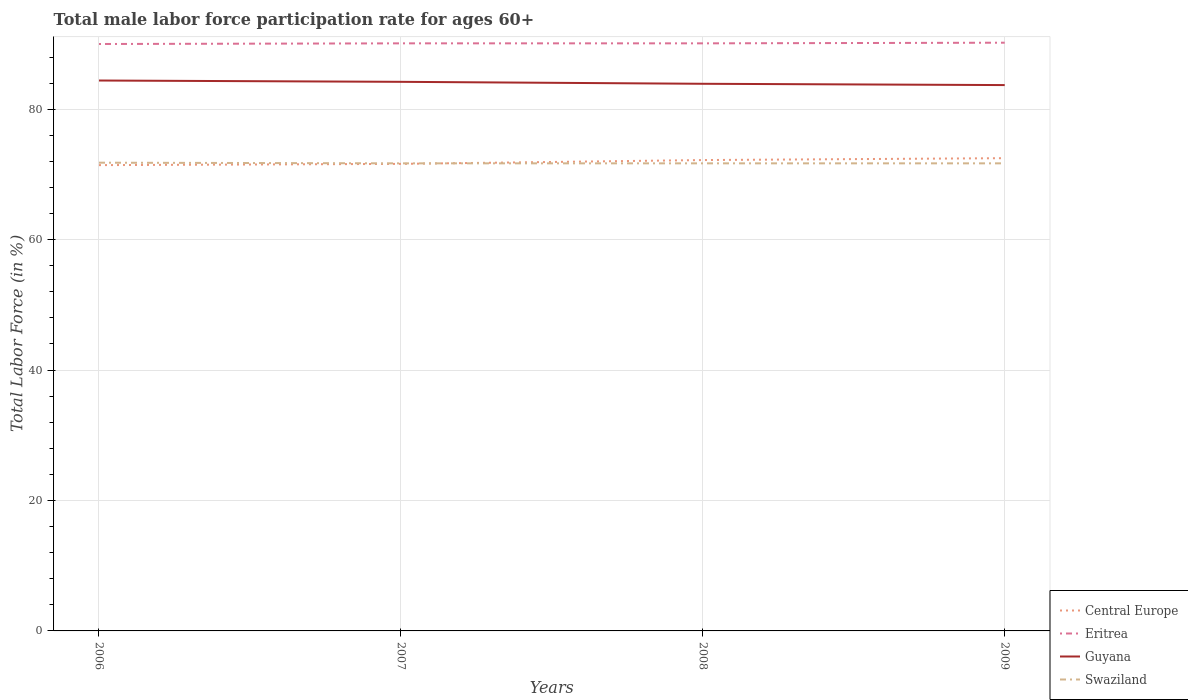How many different coloured lines are there?
Offer a very short reply. 4. Across all years, what is the maximum male labor force participation rate in Central Europe?
Your response must be concise. 71.43. What is the total male labor force participation rate in Guyana in the graph?
Your response must be concise. 0.5. What is the difference between the highest and the second highest male labor force participation rate in Swaziland?
Your answer should be compact. 0.1. What is the difference between the highest and the lowest male labor force participation rate in Eritrea?
Provide a succinct answer. 1. Is the male labor force participation rate in Swaziland strictly greater than the male labor force participation rate in Central Europe over the years?
Provide a short and direct response. No. How many lines are there?
Give a very brief answer. 4. What is the difference between two consecutive major ticks on the Y-axis?
Offer a terse response. 20. Are the values on the major ticks of Y-axis written in scientific E-notation?
Your answer should be very brief. No. Does the graph contain any zero values?
Make the answer very short. No. Where does the legend appear in the graph?
Give a very brief answer. Bottom right. What is the title of the graph?
Keep it short and to the point. Total male labor force participation rate for ages 60+. Does "Barbados" appear as one of the legend labels in the graph?
Provide a short and direct response. No. What is the label or title of the X-axis?
Ensure brevity in your answer.  Years. What is the label or title of the Y-axis?
Your answer should be very brief. Total Labor Force (in %). What is the Total Labor Force (in %) in Central Europe in 2006?
Offer a very short reply. 71.43. What is the Total Labor Force (in %) of Eritrea in 2006?
Ensure brevity in your answer.  90. What is the Total Labor Force (in %) of Guyana in 2006?
Make the answer very short. 84.4. What is the Total Labor Force (in %) of Swaziland in 2006?
Your answer should be very brief. 71.8. What is the Total Labor Force (in %) in Central Europe in 2007?
Offer a terse response. 71.62. What is the Total Labor Force (in %) of Eritrea in 2007?
Make the answer very short. 90.1. What is the Total Labor Force (in %) in Guyana in 2007?
Offer a very short reply. 84.2. What is the Total Labor Force (in %) in Swaziland in 2007?
Your answer should be very brief. 71.7. What is the Total Labor Force (in %) of Central Europe in 2008?
Offer a terse response. 72.2. What is the Total Labor Force (in %) in Eritrea in 2008?
Make the answer very short. 90.1. What is the Total Labor Force (in %) of Guyana in 2008?
Offer a very short reply. 83.9. What is the Total Labor Force (in %) in Swaziland in 2008?
Give a very brief answer. 71.7. What is the Total Labor Force (in %) of Central Europe in 2009?
Ensure brevity in your answer.  72.49. What is the Total Labor Force (in %) of Eritrea in 2009?
Provide a succinct answer. 90.2. What is the Total Labor Force (in %) in Guyana in 2009?
Offer a terse response. 83.7. What is the Total Labor Force (in %) of Swaziland in 2009?
Keep it short and to the point. 71.7. Across all years, what is the maximum Total Labor Force (in %) of Central Europe?
Offer a terse response. 72.49. Across all years, what is the maximum Total Labor Force (in %) in Eritrea?
Keep it short and to the point. 90.2. Across all years, what is the maximum Total Labor Force (in %) of Guyana?
Your answer should be compact. 84.4. Across all years, what is the maximum Total Labor Force (in %) of Swaziland?
Make the answer very short. 71.8. Across all years, what is the minimum Total Labor Force (in %) of Central Europe?
Your answer should be compact. 71.43. Across all years, what is the minimum Total Labor Force (in %) of Guyana?
Offer a terse response. 83.7. Across all years, what is the minimum Total Labor Force (in %) in Swaziland?
Ensure brevity in your answer.  71.7. What is the total Total Labor Force (in %) in Central Europe in the graph?
Your response must be concise. 287.74. What is the total Total Labor Force (in %) in Eritrea in the graph?
Ensure brevity in your answer.  360.4. What is the total Total Labor Force (in %) of Guyana in the graph?
Your answer should be compact. 336.2. What is the total Total Labor Force (in %) of Swaziland in the graph?
Your answer should be very brief. 286.9. What is the difference between the Total Labor Force (in %) in Central Europe in 2006 and that in 2007?
Make the answer very short. -0.19. What is the difference between the Total Labor Force (in %) of Eritrea in 2006 and that in 2007?
Ensure brevity in your answer.  -0.1. What is the difference between the Total Labor Force (in %) in Guyana in 2006 and that in 2007?
Make the answer very short. 0.2. What is the difference between the Total Labor Force (in %) in Central Europe in 2006 and that in 2008?
Provide a short and direct response. -0.78. What is the difference between the Total Labor Force (in %) in Guyana in 2006 and that in 2008?
Make the answer very short. 0.5. What is the difference between the Total Labor Force (in %) in Central Europe in 2006 and that in 2009?
Offer a very short reply. -1.07. What is the difference between the Total Labor Force (in %) in Guyana in 2006 and that in 2009?
Provide a succinct answer. 0.7. What is the difference between the Total Labor Force (in %) of Central Europe in 2007 and that in 2008?
Keep it short and to the point. -0.59. What is the difference between the Total Labor Force (in %) of Eritrea in 2007 and that in 2008?
Provide a short and direct response. 0. What is the difference between the Total Labor Force (in %) in Swaziland in 2007 and that in 2008?
Your response must be concise. 0. What is the difference between the Total Labor Force (in %) of Central Europe in 2007 and that in 2009?
Give a very brief answer. -0.88. What is the difference between the Total Labor Force (in %) in Eritrea in 2007 and that in 2009?
Give a very brief answer. -0.1. What is the difference between the Total Labor Force (in %) in Swaziland in 2007 and that in 2009?
Make the answer very short. 0. What is the difference between the Total Labor Force (in %) of Central Europe in 2008 and that in 2009?
Give a very brief answer. -0.29. What is the difference between the Total Labor Force (in %) in Eritrea in 2008 and that in 2009?
Keep it short and to the point. -0.1. What is the difference between the Total Labor Force (in %) in Central Europe in 2006 and the Total Labor Force (in %) in Eritrea in 2007?
Your answer should be very brief. -18.67. What is the difference between the Total Labor Force (in %) in Central Europe in 2006 and the Total Labor Force (in %) in Guyana in 2007?
Provide a short and direct response. -12.77. What is the difference between the Total Labor Force (in %) in Central Europe in 2006 and the Total Labor Force (in %) in Swaziland in 2007?
Your answer should be compact. -0.27. What is the difference between the Total Labor Force (in %) in Eritrea in 2006 and the Total Labor Force (in %) in Guyana in 2007?
Offer a terse response. 5.8. What is the difference between the Total Labor Force (in %) of Eritrea in 2006 and the Total Labor Force (in %) of Swaziland in 2007?
Provide a short and direct response. 18.3. What is the difference between the Total Labor Force (in %) in Central Europe in 2006 and the Total Labor Force (in %) in Eritrea in 2008?
Keep it short and to the point. -18.67. What is the difference between the Total Labor Force (in %) in Central Europe in 2006 and the Total Labor Force (in %) in Guyana in 2008?
Your response must be concise. -12.47. What is the difference between the Total Labor Force (in %) of Central Europe in 2006 and the Total Labor Force (in %) of Swaziland in 2008?
Ensure brevity in your answer.  -0.27. What is the difference between the Total Labor Force (in %) of Eritrea in 2006 and the Total Labor Force (in %) of Guyana in 2008?
Provide a succinct answer. 6.1. What is the difference between the Total Labor Force (in %) of Eritrea in 2006 and the Total Labor Force (in %) of Swaziland in 2008?
Ensure brevity in your answer.  18.3. What is the difference between the Total Labor Force (in %) of Guyana in 2006 and the Total Labor Force (in %) of Swaziland in 2008?
Provide a succinct answer. 12.7. What is the difference between the Total Labor Force (in %) in Central Europe in 2006 and the Total Labor Force (in %) in Eritrea in 2009?
Keep it short and to the point. -18.77. What is the difference between the Total Labor Force (in %) of Central Europe in 2006 and the Total Labor Force (in %) of Guyana in 2009?
Provide a succinct answer. -12.27. What is the difference between the Total Labor Force (in %) of Central Europe in 2006 and the Total Labor Force (in %) of Swaziland in 2009?
Make the answer very short. -0.27. What is the difference between the Total Labor Force (in %) of Eritrea in 2006 and the Total Labor Force (in %) of Guyana in 2009?
Ensure brevity in your answer.  6.3. What is the difference between the Total Labor Force (in %) in Eritrea in 2006 and the Total Labor Force (in %) in Swaziland in 2009?
Offer a very short reply. 18.3. What is the difference between the Total Labor Force (in %) of Central Europe in 2007 and the Total Labor Force (in %) of Eritrea in 2008?
Provide a succinct answer. -18.48. What is the difference between the Total Labor Force (in %) of Central Europe in 2007 and the Total Labor Force (in %) of Guyana in 2008?
Provide a short and direct response. -12.28. What is the difference between the Total Labor Force (in %) in Central Europe in 2007 and the Total Labor Force (in %) in Swaziland in 2008?
Ensure brevity in your answer.  -0.08. What is the difference between the Total Labor Force (in %) in Eritrea in 2007 and the Total Labor Force (in %) in Guyana in 2008?
Keep it short and to the point. 6.2. What is the difference between the Total Labor Force (in %) in Eritrea in 2007 and the Total Labor Force (in %) in Swaziland in 2008?
Offer a very short reply. 18.4. What is the difference between the Total Labor Force (in %) in Guyana in 2007 and the Total Labor Force (in %) in Swaziland in 2008?
Provide a short and direct response. 12.5. What is the difference between the Total Labor Force (in %) of Central Europe in 2007 and the Total Labor Force (in %) of Eritrea in 2009?
Make the answer very short. -18.58. What is the difference between the Total Labor Force (in %) in Central Europe in 2007 and the Total Labor Force (in %) in Guyana in 2009?
Give a very brief answer. -12.08. What is the difference between the Total Labor Force (in %) of Central Europe in 2007 and the Total Labor Force (in %) of Swaziland in 2009?
Offer a very short reply. -0.08. What is the difference between the Total Labor Force (in %) of Eritrea in 2007 and the Total Labor Force (in %) of Guyana in 2009?
Make the answer very short. 6.4. What is the difference between the Total Labor Force (in %) of Guyana in 2007 and the Total Labor Force (in %) of Swaziland in 2009?
Provide a succinct answer. 12.5. What is the difference between the Total Labor Force (in %) of Central Europe in 2008 and the Total Labor Force (in %) of Eritrea in 2009?
Offer a very short reply. -18. What is the difference between the Total Labor Force (in %) of Central Europe in 2008 and the Total Labor Force (in %) of Guyana in 2009?
Offer a terse response. -11.5. What is the difference between the Total Labor Force (in %) of Central Europe in 2008 and the Total Labor Force (in %) of Swaziland in 2009?
Provide a succinct answer. 0.5. What is the difference between the Total Labor Force (in %) in Guyana in 2008 and the Total Labor Force (in %) in Swaziland in 2009?
Provide a succinct answer. 12.2. What is the average Total Labor Force (in %) of Central Europe per year?
Keep it short and to the point. 71.93. What is the average Total Labor Force (in %) in Eritrea per year?
Give a very brief answer. 90.1. What is the average Total Labor Force (in %) in Guyana per year?
Keep it short and to the point. 84.05. What is the average Total Labor Force (in %) in Swaziland per year?
Make the answer very short. 71.72. In the year 2006, what is the difference between the Total Labor Force (in %) of Central Europe and Total Labor Force (in %) of Eritrea?
Provide a short and direct response. -18.57. In the year 2006, what is the difference between the Total Labor Force (in %) of Central Europe and Total Labor Force (in %) of Guyana?
Give a very brief answer. -12.97. In the year 2006, what is the difference between the Total Labor Force (in %) in Central Europe and Total Labor Force (in %) in Swaziland?
Offer a terse response. -0.37. In the year 2006, what is the difference between the Total Labor Force (in %) of Eritrea and Total Labor Force (in %) of Guyana?
Offer a very short reply. 5.6. In the year 2006, what is the difference between the Total Labor Force (in %) of Eritrea and Total Labor Force (in %) of Swaziland?
Give a very brief answer. 18.2. In the year 2006, what is the difference between the Total Labor Force (in %) of Guyana and Total Labor Force (in %) of Swaziland?
Offer a terse response. 12.6. In the year 2007, what is the difference between the Total Labor Force (in %) in Central Europe and Total Labor Force (in %) in Eritrea?
Your response must be concise. -18.48. In the year 2007, what is the difference between the Total Labor Force (in %) of Central Europe and Total Labor Force (in %) of Guyana?
Provide a succinct answer. -12.58. In the year 2007, what is the difference between the Total Labor Force (in %) of Central Europe and Total Labor Force (in %) of Swaziland?
Provide a short and direct response. -0.08. In the year 2007, what is the difference between the Total Labor Force (in %) in Guyana and Total Labor Force (in %) in Swaziland?
Offer a very short reply. 12.5. In the year 2008, what is the difference between the Total Labor Force (in %) of Central Europe and Total Labor Force (in %) of Eritrea?
Keep it short and to the point. -17.9. In the year 2008, what is the difference between the Total Labor Force (in %) in Central Europe and Total Labor Force (in %) in Guyana?
Make the answer very short. -11.7. In the year 2008, what is the difference between the Total Labor Force (in %) of Central Europe and Total Labor Force (in %) of Swaziland?
Your response must be concise. 0.5. In the year 2008, what is the difference between the Total Labor Force (in %) in Eritrea and Total Labor Force (in %) in Guyana?
Offer a very short reply. 6.2. In the year 2009, what is the difference between the Total Labor Force (in %) of Central Europe and Total Labor Force (in %) of Eritrea?
Keep it short and to the point. -17.71. In the year 2009, what is the difference between the Total Labor Force (in %) of Central Europe and Total Labor Force (in %) of Guyana?
Offer a terse response. -11.21. In the year 2009, what is the difference between the Total Labor Force (in %) in Central Europe and Total Labor Force (in %) in Swaziland?
Keep it short and to the point. 0.79. In the year 2009, what is the difference between the Total Labor Force (in %) of Eritrea and Total Labor Force (in %) of Guyana?
Your answer should be compact. 6.5. In the year 2009, what is the difference between the Total Labor Force (in %) in Guyana and Total Labor Force (in %) in Swaziland?
Make the answer very short. 12. What is the ratio of the Total Labor Force (in %) in Eritrea in 2006 to that in 2007?
Provide a short and direct response. 1. What is the ratio of the Total Labor Force (in %) in Swaziland in 2006 to that in 2007?
Offer a terse response. 1. What is the ratio of the Total Labor Force (in %) in Central Europe in 2006 to that in 2008?
Ensure brevity in your answer.  0.99. What is the ratio of the Total Labor Force (in %) in Swaziland in 2006 to that in 2008?
Offer a very short reply. 1. What is the ratio of the Total Labor Force (in %) in Guyana in 2006 to that in 2009?
Keep it short and to the point. 1.01. What is the ratio of the Total Labor Force (in %) in Swaziland in 2006 to that in 2009?
Make the answer very short. 1. What is the ratio of the Total Labor Force (in %) of Eritrea in 2007 to that in 2008?
Ensure brevity in your answer.  1. What is the ratio of the Total Labor Force (in %) of Guyana in 2007 to that in 2008?
Provide a short and direct response. 1. What is the ratio of the Total Labor Force (in %) in Swaziland in 2007 to that in 2008?
Ensure brevity in your answer.  1. What is the ratio of the Total Labor Force (in %) in Central Europe in 2007 to that in 2009?
Offer a terse response. 0.99. What is the ratio of the Total Labor Force (in %) of Eritrea in 2007 to that in 2009?
Give a very brief answer. 1. What is the ratio of the Total Labor Force (in %) of Guyana in 2007 to that in 2009?
Ensure brevity in your answer.  1.01. What is the ratio of the Total Labor Force (in %) of Swaziland in 2008 to that in 2009?
Offer a terse response. 1. What is the difference between the highest and the second highest Total Labor Force (in %) of Central Europe?
Provide a short and direct response. 0.29. What is the difference between the highest and the second highest Total Labor Force (in %) in Eritrea?
Give a very brief answer. 0.1. What is the difference between the highest and the lowest Total Labor Force (in %) in Central Europe?
Provide a succinct answer. 1.07. What is the difference between the highest and the lowest Total Labor Force (in %) in Swaziland?
Offer a very short reply. 0.1. 